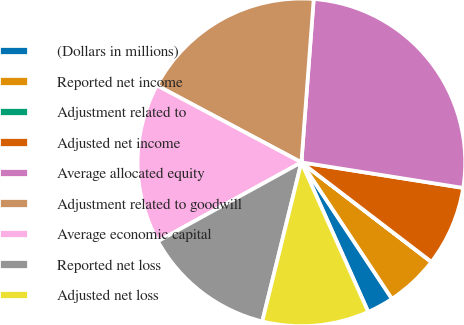<chart> <loc_0><loc_0><loc_500><loc_500><pie_chart><fcel>(Dollars in millions)<fcel>Reported net income<fcel>Adjustment related to<fcel>Adjusted net income<fcel>Average allocated equity<fcel>Adjustment related to goodwill<fcel>Average economic capital<fcel>Reported net loss<fcel>Adjusted net loss<nl><fcel>2.64%<fcel>5.27%<fcel>0.01%<fcel>7.9%<fcel>26.3%<fcel>18.41%<fcel>15.79%<fcel>13.16%<fcel>10.53%<nl></chart> 